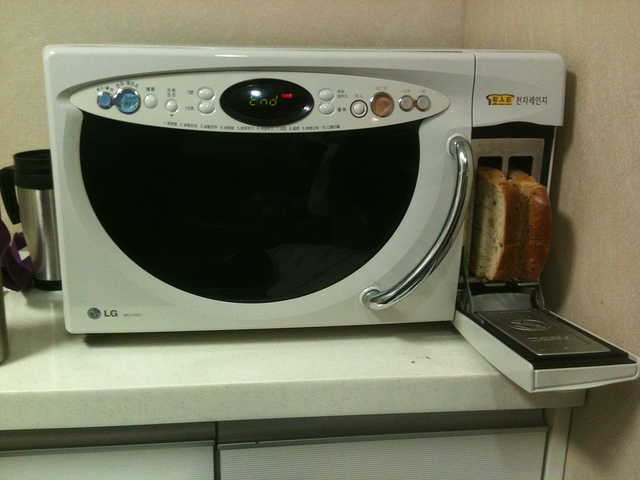Please extract the text content from this image. LG End 